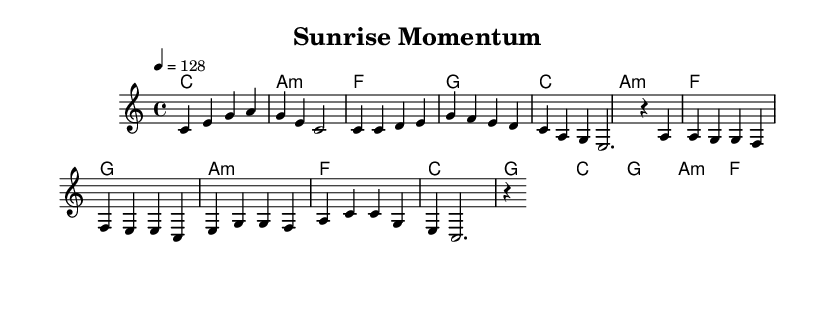What is the key signature of this music? The key signature is C major, which has no sharps or flats.
Answer: C major What is the time signature of the piece? The time signature shown is 4/4, which means there are four beats in a measure and the quarter note gets one beat.
Answer: 4/4 What is the tempo marking for this piece? The tempo marking indicates a speed of 128 beats per minute, which is indicated with the notation "4 = 128".
Answer: 128 Name the first chord of the intro. The first chord in the intro is clearly indicated as a C major chord.
Answer: C How many measures are in the chorus section? There are four measures in the chorus section, as it consists of two lines of music with two measures each.
Answer: 4 What is the last chord in the pre-chorus? The last chord in the pre-chorus is a G major chord. This can be determined by analyzing the final chord presented in the sequence of chords during that section.
Answer: G What characteristic rhythm is typical of upbeat Latin pop music seen in this piece? The piece employs a consistent rhythm with a lively tempo, characterized by a combination of quarter notes and dotted rhythms, which adds to its upbeat feel.
Answer: Dotted rhythms 